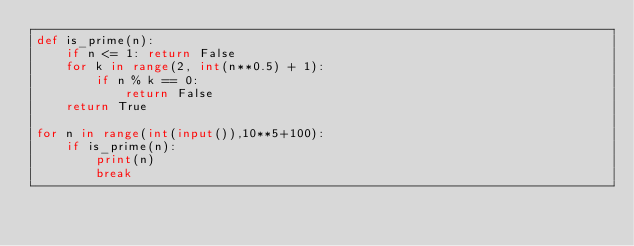Convert code to text. <code><loc_0><loc_0><loc_500><loc_500><_Python_>def is_prime(n):
    if n <= 1: return False
    for k in range(2, int(n**0.5) + 1):
        if n % k == 0:
            return False
    return True

for n in range(int(input()),10**5+100):
    if is_prime(n):
        print(n)
        break</code> 